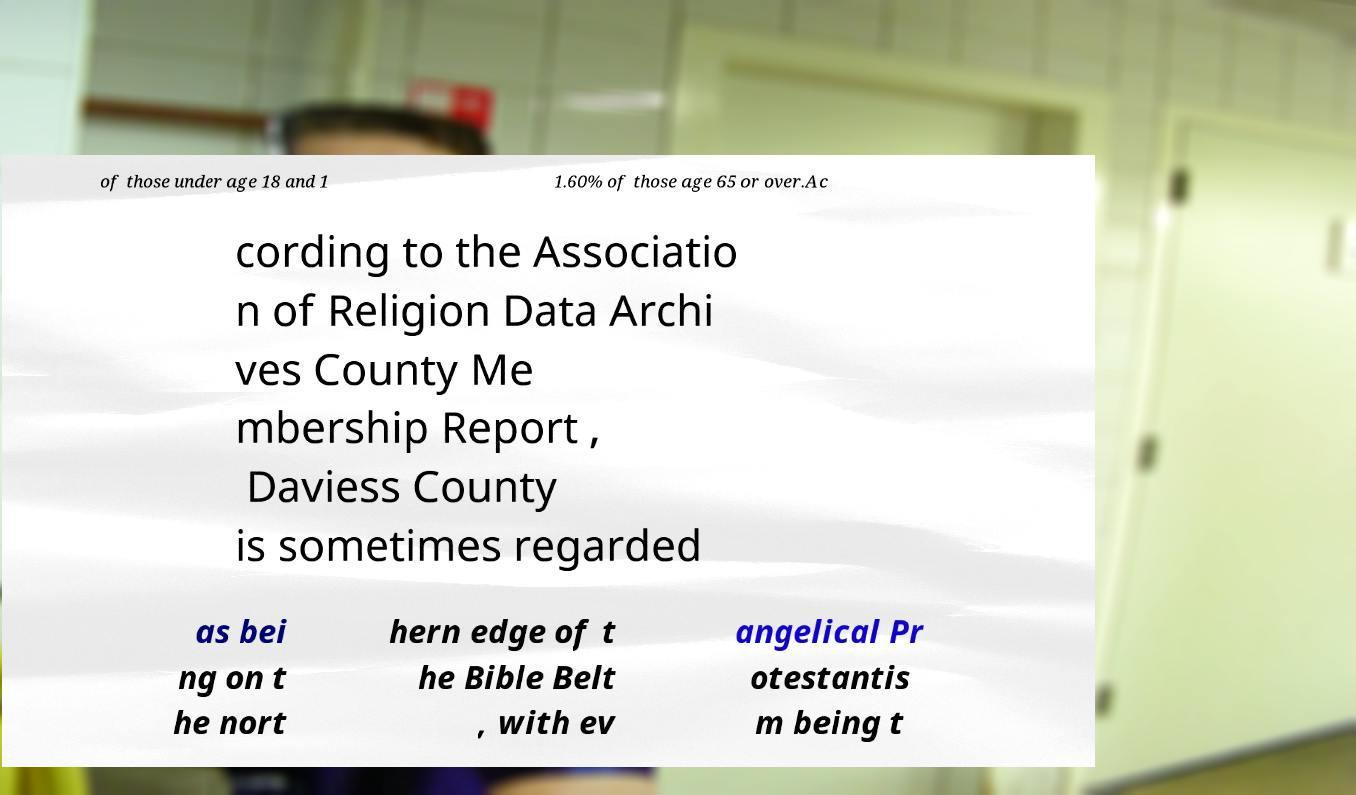Please read and relay the text visible in this image. What does it say? of those under age 18 and 1 1.60% of those age 65 or over.Ac cording to the Associatio n of Religion Data Archi ves County Me mbership Report , Daviess County is sometimes regarded as bei ng on t he nort hern edge of t he Bible Belt , with ev angelical Pr otestantis m being t 